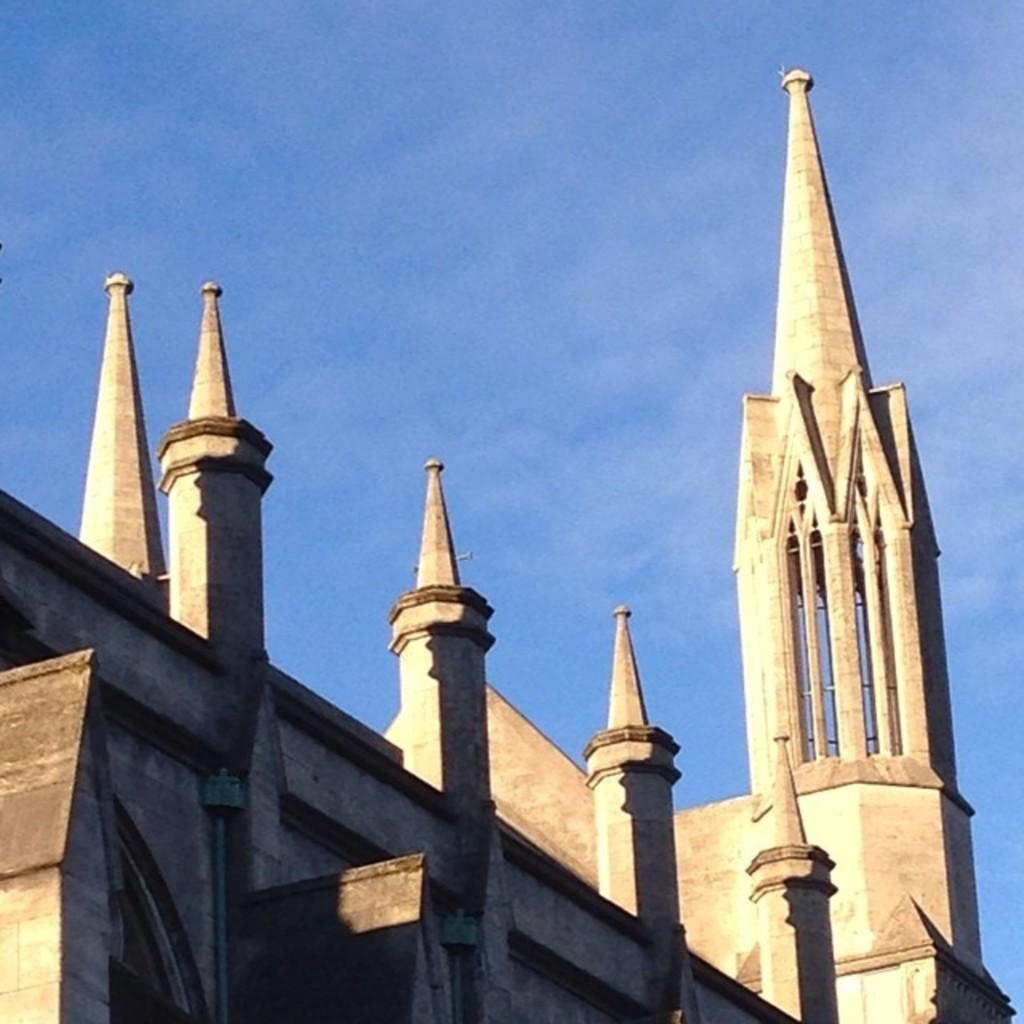What is the main subject in the picture? There is a building in the picture. What can be seen in the background of the picture? The sky is visible in the background of the picture. What type of steel is used to construct the building in the image? There is no information about the type of steel used in the construction of the building in the image. How many screws can be seen on the building in the image? There is no mention of screws in the image, so it is impossible to determine the number of screws present. 